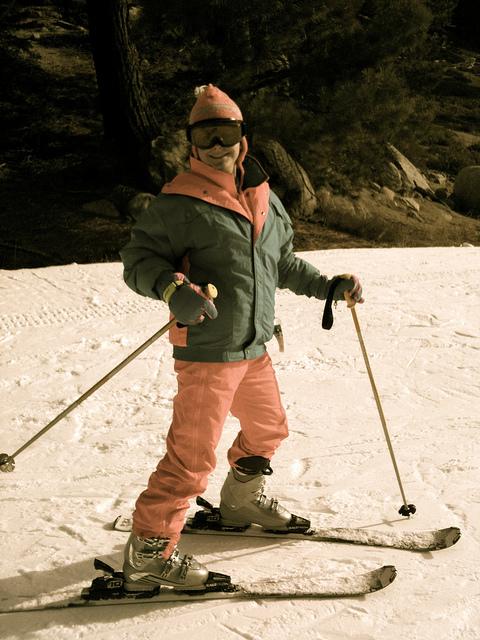What do you call the items in the person's hands?
Answer briefly. Ski poles. What is the person riding?
Concise answer only. Skis. Is this person wearing goggles?
Keep it brief. Yes. 